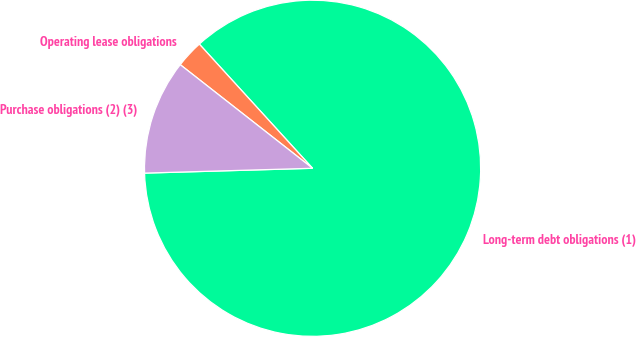<chart> <loc_0><loc_0><loc_500><loc_500><pie_chart><fcel>Long-term debt obligations (1)<fcel>Operating lease obligations<fcel>Purchase obligations (2) (3)<nl><fcel>86.31%<fcel>2.66%<fcel>11.03%<nl></chart> 